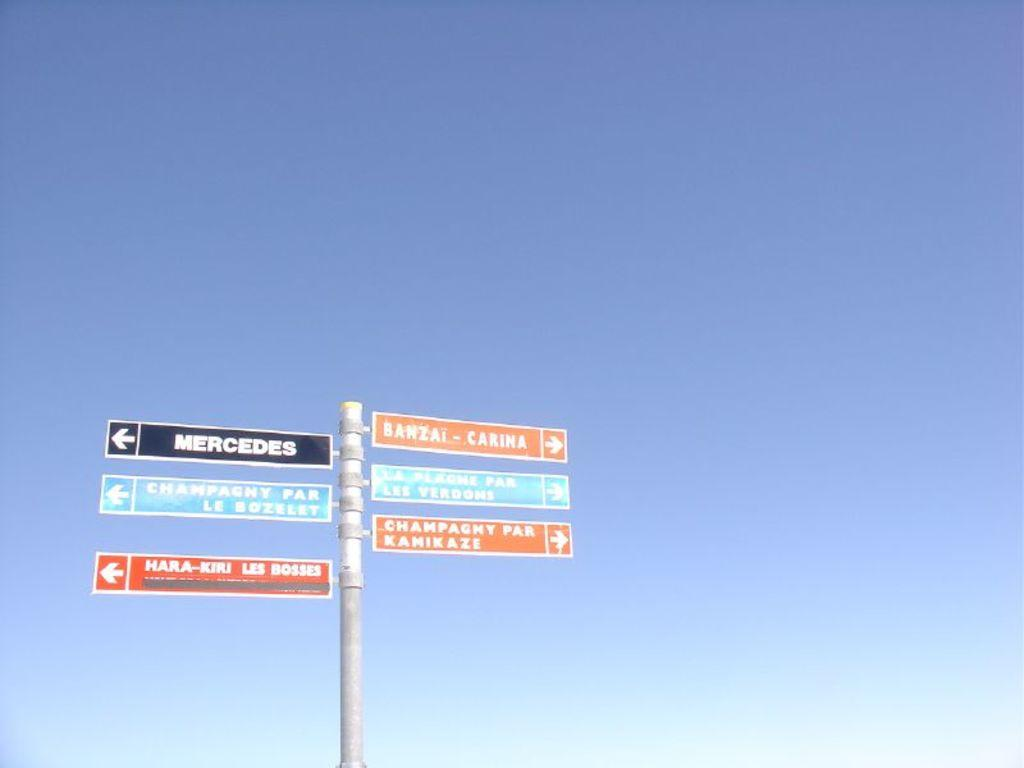<image>
Write a terse but informative summary of the picture. Different signs like a directory saying Mercedes to the left and Banzai to the right. 